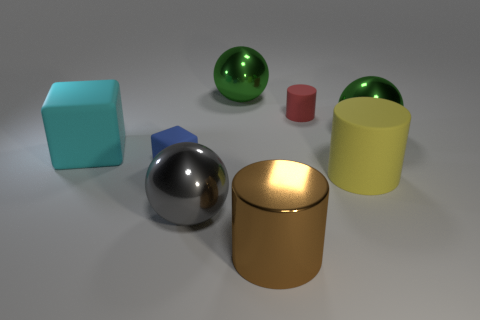Is there any other thing of the same color as the tiny matte cylinder?
Your response must be concise. No. Is the blue object made of the same material as the thing in front of the gray ball?
Give a very brief answer. No. What is the material of the other big thing that is the same shape as the large yellow object?
Your response must be concise. Metal. Do the small object to the left of the small red cylinder and the large cylinder to the right of the large metallic cylinder have the same material?
Make the answer very short. Yes. There is a block behind the tiny object that is in front of the tiny thing behind the big cyan thing; what color is it?
Keep it short and to the point. Cyan. What number of other things are there of the same shape as the red matte object?
Ensure brevity in your answer.  2. Do the metallic cylinder and the big matte cube have the same color?
Offer a terse response. No. How many things are cubes or gray spheres that are on the right side of the big cyan object?
Your answer should be very brief. 3. Are there any yellow metal blocks of the same size as the yellow thing?
Offer a terse response. No. Is the material of the large brown thing the same as the red object?
Offer a terse response. No. 